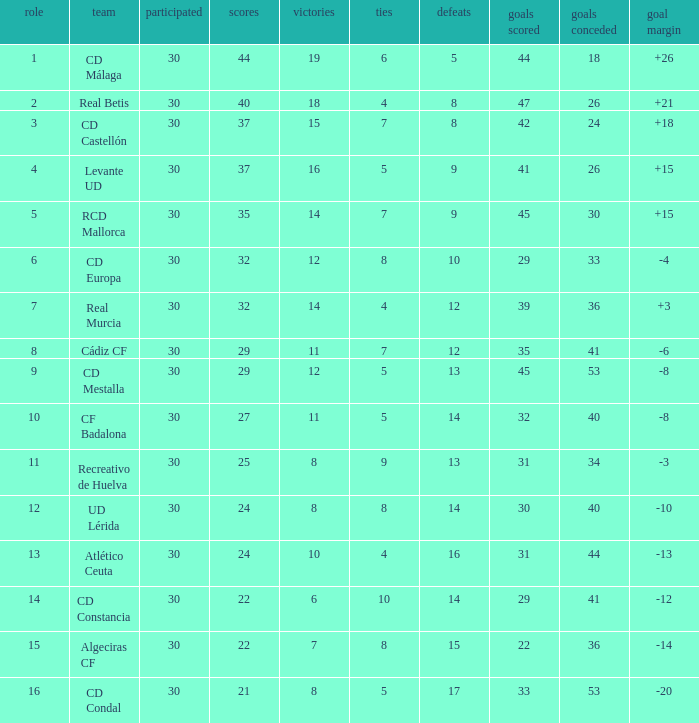What is the wins number when the points were smaller than 27, and goals against was 41? 6.0. 